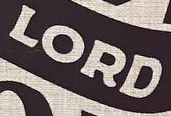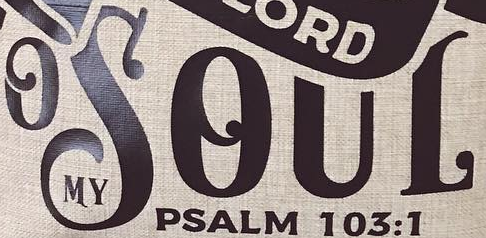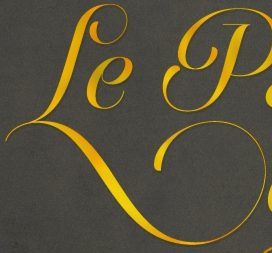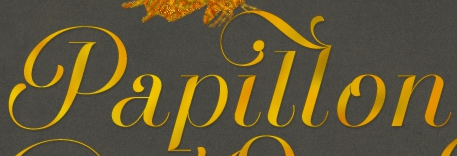Read the text content from these images in order, separated by a semicolon. LORD; OSOUL; Le; Papillon 